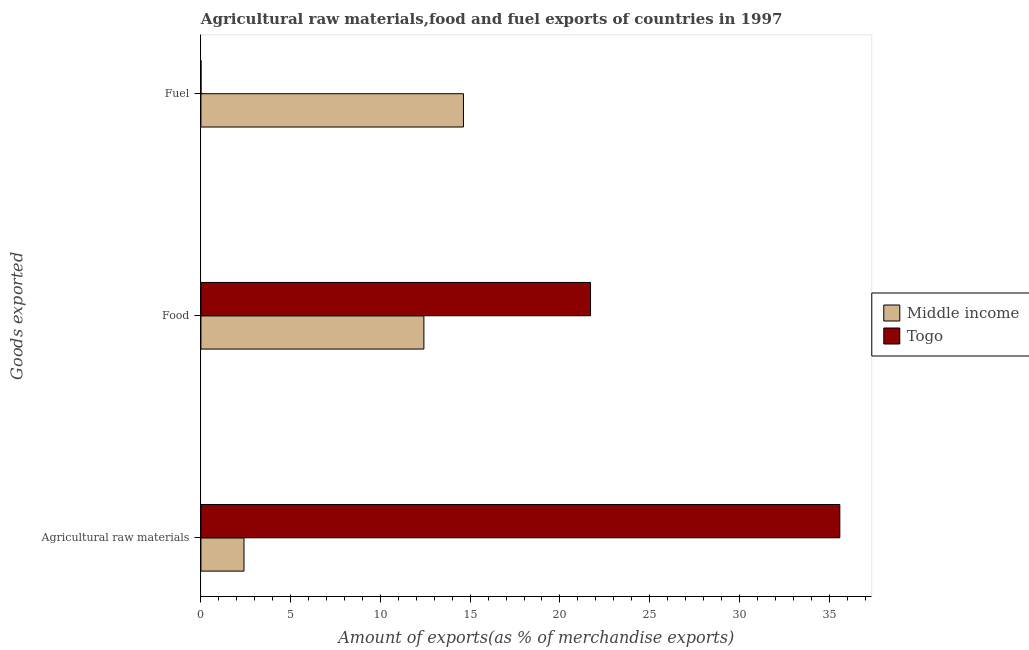Are the number of bars per tick equal to the number of legend labels?
Ensure brevity in your answer.  Yes. Are the number of bars on each tick of the Y-axis equal?
Offer a terse response. Yes. How many bars are there on the 3rd tick from the top?
Your response must be concise. 2. What is the label of the 1st group of bars from the top?
Offer a very short reply. Fuel. What is the percentage of raw materials exports in Middle income?
Provide a short and direct response. 2.4. Across all countries, what is the maximum percentage of raw materials exports?
Make the answer very short. 35.59. Across all countries, what is the minimum percentage of food exports?
Provide a succinct answer. 12.42. In which country was the percentage of raw materials exports maximum?
Provide a succinct answer. Togo. In which country was the percentage of fuel exports minimum?
Offer a very short reply. Togo. What is the total percentage of raw materials exports in the graph?
Your answer should be very brief. 37.99. What is the difference between the percentage of raw materials exports in Middle income and that in Togo?
Offer a very short reply. -33.19. What is the difference between the percentage of food exports in Middle income and the percentage of fuel exports in Togo?
Provide a short and direct response. 12.42. What is the average percentage of food exports per country?
Keep it short and to the point. 17.06. What is the difference between the percentage of raw materials exports and percentage of food exports in Togo?
Give a very brief answer. 13.89. What is the ratio of the percentage of fuel exports in Togo to that in Middle income?
Offer a very short reply. 0. Is the percentage of fuel exports in Middle income less than that in Togo?
Provide a succinct answer. No. Is the difference between the percentage of raw materials exports in Togo and Middle income greater than the difference between the percentage of fuel exports in Togo and Middle income?
Offer a terse response. Yes. What is the difference between the highest and the second highest percentage of raw materials exports?
Provide a succinct answer. 33.19. What is the difference between the highest and the lowest percentage of food exports?
Offer a very short reply. 9.28. In how many countries, is the percentage of food exports greater than the average percentage of food exports taken over all countries?
Ensure brevity in your answer.  1. What does the 2nd bar from the top in Agricultural raw materials represents?
Offer a terse response. Middle income. Is it the case that in every country, the sum of the percentage of raw materials exports and percentage of food exports is greater than the percentage of fuel exports?
Offer a terse response. Yes. Are all the bars in the graph horizontal?
Ensure brevity in your answer.  Yes. How many legend labels are there?
Your answer should be very brief. 2. How are the legend labels stacked?
Provide a short and direct response. Vertical. What is the title of the graph?
Keep it short and to the point. Agricultural raw materials,food and fuel exports of countries in 1997. Does "Middle East & North Africa (developing only)" appear as one of the legend labels in the graph?
Ensure brevity in your answer.  No. What is the label or title of the X-axis?
Give a very brief answer. Amount of exports(as % of merchandise exports). What is the label or title of the Y-axis?
Make the answer very short. Goods exported. What is the Amount of exports(as % of merchandise exports) in Middle income in Agricultural raw materials?
Provide a succinct answer. 2.4. What is the Amount of exports(as % of merchandise exports) of Togo in Agricultural raw materials?
Keep it short and to the point. 35.59. What is the Amount of exports(as % of merchandise exports) of Middle income in Food?
Keep it short and to the point. 12.42. What is the Amount of exports(as % of merchandise exports) in Togo in Food?
Keep it short and to the point. 21.7. What is the Amount of exports(as % of merchandise exports) in Middle income in Fuel?
Your answer should be very brief. 14.62. What is the Amount of exports(as % of merchandise exports) of Togo in Fuel?
Keep it short and to the point. 0. Across all Goods exported, what is the maximum Amount of exports(as % of merchandise exports) of Middle income?
Offer a terse response. 14.62. Across all Goods exported, what is the maximum Amount of exports(as % of merchandise exports) in Togo?
Provide a succinct answer. 35.59. Across all Goods exported, what is the minimum Amount of exports(as % of merchandise exports) in Middle income?
Your answer should be compact. 2.4. Across all Goods exported, what is the minimum Amount of exports(as % of merchandise exports) in Togo?
Your answer should be very brief. 0. What is the total Amount of exports(as % of merchandise exports) in Middle income in the graph?
Ensure brevity in your answer.  29.45. What is the total Amount of exports(as % of merchandise exports) of Togo in the graph?
Offer a terse response. 57.3. What is the difference between the Amount of exports(as % of merchandise exports) of Middle income in Agricultural raw materials and that in Food?
Offer a terse response. -10.02. What is the difference between the Amount of exports(as % of merchandise exports) in Togo in Agricultural raw materials and that in Food?
Give a very brief answer. 13.89. What is the difference between the Amount of exports(as % of merchandise exports) of Middle income in Agricultural raw materials and that in Fuel?
Make the answer very short. -12.23. What is the difference between the Amount of exports(as % of merchandise exports) of Togo in Agricultural raw materials and that in Fuel?
Keep it short and to the point. 35.59. What is the difference between the Amount of exports(as % of merchandise exports) of Middle income in Food and that in Fuel?
Your answer should be compact. -2.2. What is the difference between the Amount of exports(as % of merchandise exports) of Togo in Food and that in Fuel?
Give a very brief answer. 21.7. What is the difference between the Amount of exports(as % of merchandise exports) in Middle income in Agricultural raw materials and the Amount of exports(as % of merchandise exports) in Togo in Food?
Provide a succinct answer. -19.3. What is the difference between the Amount of exports(as % of merchandise exports) of Middle income in Agricultural raw materials and the Amount of exports(as % of merchandise exports) of Togo in Fuel?
Keep it short and to the point. 2.4. What is the difference between the Amount of exports(as % of merchandise exports) in Middle income in Food and the Amount of exports(as % of merchandise exports) in Togo in Fuel?
Provide a short and direct response. 12.42. What is the average Amount of exports(as % of merchandise exports) of Middle income per Goods exported?
Make the answer very short. 9.82. What is the average Amount of exports(as % of merchandise exports) of Togo per Goods exported?
Give a very brief answer. 19.1. What is the difference between the Amount of exports(as % of merchandise exports) of Middle income and Amount of exports(as % of merchandise exports) of Togo in Agricultural raw materials?
Your answer should be compact. -33.19. What is the difference between the Amount of exports(as % of merchandise exports) of Middle income and Amount of exports(as % of merchandise exports) of Togo in Food?
Your response must be concise. -9.28. What is the difference between the Amount of exports(as % of merchandise exports) in Middle income and Amount of exports(as % of merchandise exports) in Togo in Fuel?
Offer a very short reply. 14.62. What is the ratio of the Amount of exports(as % of merchandise exports) in Middle income in Agricultural raw materials to that in Food?
Provide a short and direct response. 0.19. What is the ratio of the Amount of exports(as % of merchandise exports) of Togo in Agricultural raw materials to that in Food?
Your answer should be very brief. 1.64. What is the ratio of the Amount of exports(as % of merchandise exports) in Middle income in Agricultural raw materials to that in Fuel?
Give a very brief answer. 0.16. What is the ratio of the Amount of exports(as % of merchandise exports) in Togo in Agricultural raw materials to that in Fuel?
Keep it short and to the point. 1.34e+04. What is the ratio of the Amount of exports(as % of merchandise exports) in Middle income in Food to that in Fuel?
Make the answer very short. 0.85. What is the ratio of the Amount of exports(as % of merchandise exports) in Togo in Food to that in Fuel?
Offer a very short reply. 8164.93. What is the difference between the highest and the second highest Amount of exports(as % of merchandise exports) of Middle income?
Offer a very short reply. 2.2. What is the difference between the highest and the second highest Amount of exports(as % of merchandise exports) of Togo?
Give a very brief answer. 13.89. What is the difference between the highest and the lowest Amount of exports(as % of merchandise exports) in Middle income?
Make the answer very short. 12.23. What is the difference between the highest and the lowest Amount of exports(as % of merchandise exports) in Togo?
Give a very brief answer. 35.59. 